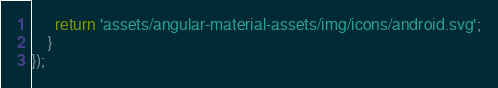Convert code to text. <code><loc_0><loc_0><loc_500><loc_500><_JavaScript_>      return 'assets/angular-material-assets/img/icons/android.svg';
    }
});
</code> 